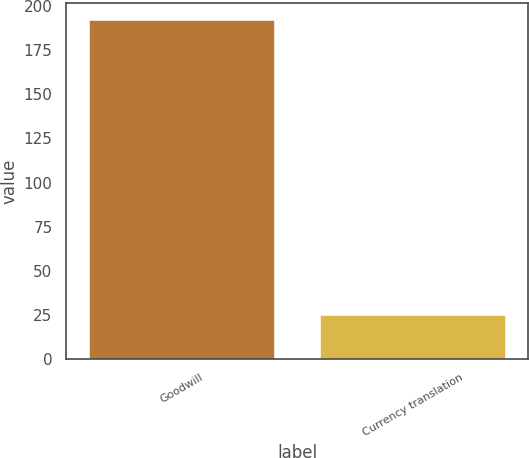Convert chart to OTSL. <chart><loc_0><loc_0><loc_500><loc_500><bar_chart><fcel>Goodwill<fcel>Currency translation<nl><fcel>192.3<fcel>25.1<nl></chart> 